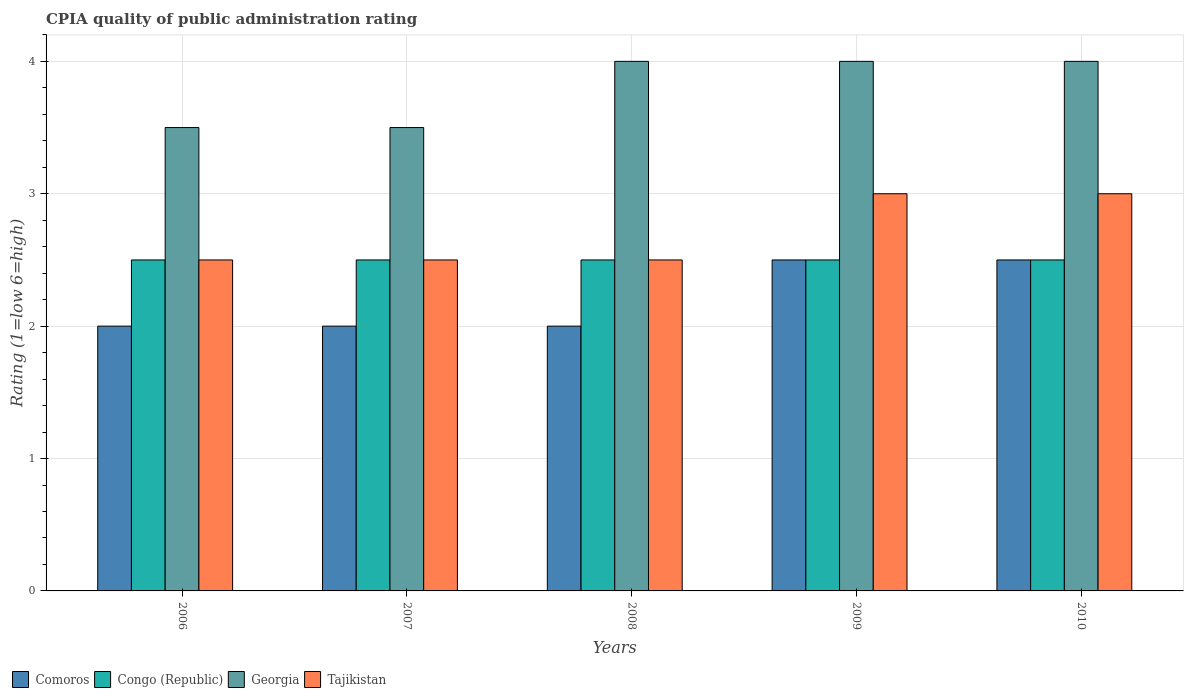How many different coloured bars are there?
Offer a terse response. 4. How many groups of bars are there?
Your response must be concise. 5. Are the number of bars per tick equal to the number of legend labels?
Ensure brevity in your answer.  Yes. Are the number of bars on each tick of the X-axis equal?
Provide a short and direct response. Yes. How many bars are there on the 4th tick from the right?
Your answer should be very brief. 4. What is the CPIA rating in Comoros in 2009?
Your response must be concise. 2.5. In which year was the CPIA rating in Tajikistan maximum?
Provide a succinct answer. 2009. In which year was the CPIA rating in Tajikistan minimum?
Offer a terse response. 2006. What is the total CPIA rating in Tajikistan in the graph?
Your answer should be compact. 13.5. What is the difference between the CPIA rating in Tajikistan in 2007 and that in 2008?
Provide a succinct answer. 0. What is the average CPIA rating in Georgia per year?
Ensure brevity in your answer.  3.8. In the year 2010, what is the difference between the CPIA rating in Georgia and CPIA rating in Tajikistan?
Give a very brief answer. 1. In how many years, is the CPIA rating in Georgia greater than 2.6?
Ensure brevity in your answer.  5. What is the difference between the highest and the second highest CPIA rating in Comoros?
Offer a terse response. 0. Is it the case that in every year, the sum of the CPIA rating in Comoros and CPIA rating in Tajikistan is greater than the sum of CPIA rating in Congo (Republic) and CPIA rating in Georgia?
Your answer should be compact. No. What does the 2nd bar from the left in 2009 represents?
Make the answer very short. Congo (Republic). What does the 1st bar from the right in 2009 represents?
Offer a terse response. Tajikistan. How many bars are there?
Ensure brevity in your answer.  20. Does the graph contain any zero values?
Keep it short and to the point. No. Where does the legend appear in the graph?
Your response must be concise. Bottom left. How are the legend labels stacked?
Your response must be concise. Horizontal. What is the title of the graph?
Offer a terse response. CPIA quality of public administration rating. Does "Kenya" appear as one of the legend labels in the graph?
Give a very brief answer. No. What is the label or title of the X-axis?
Give a very brief answer. Years. What is the Rating (1=low 6=high) of Comoros in 2006?
Offer a very short reply. 2. What is the Rating (1=low 6=high) of Tajikistan in 2006?
Provide a succinct answer. 2.5. What is the Rating (1=low 6=high) of Congo (Republic) in 2007?
Your response must be concise. 2.5. What is the Rating (1=low 6=high) of Georgia in 2008?
Give a very brief answer. 4. What is the Rating (1=low 6=high) of Tajikistan in 2009?
Offer a terse response. 3. What is the Rating (1=low 6=high) of Tajikistan in 2010?
Keep it short and to the point. 3. Across all years, what is the maximum Rating (1=low 6=high) in Congo (Republic)?
Provide a succinct answer. 2.5. Across all years, what is the maximum Rating (1=low 6=high) in Tajikistan?
Your response must be concise. 3. Across all years, what is the minimum Rating (1=low 6=high) of Georgia?
Make the answer very short. 3.5. Across all years, what is the minimum Rating (1=low 6=high) in Tajikistan?
Provide a succinct answer. 2.5. What is the total Rating (1=low 6=high) of Comoros in the graph?
Provide a short and direct response. 11. What is the total Rating (1=low 6=high) in Congo (Republic) in the graph?
Offer a terse response. 12.5. What is the total Rating (1=low 6=high) in Georgia in the graph?
Offer a very short reply. 19. What is the total Rating (1=low 6=high) of Tajikistan in the graph?
Provide a succinct answer. 13.5. What is the difference between the Rating (1=low 6=high) in Comoros in 2006 and that in 2007?
Make the answer very short. 0. What is the difference between the Rating (1=low 6=high) in Congo (Republic) in 2006 and that in 2007?
Provide a short and direct response. 0. What is the difference between the Rating (1=low 6=high) of Georgia in 2006 and that in 2007?
Keep it short and to the point. 0. What is the difference between the Rating (1=low 6=high) of Tajikistan in 2006 and that in 2007?
Provide a short and direct response. 0. What is the difference between the Rating (1=low 6=high) in Comoros in 2006 and that in 2008?
Offer a very short reply. 0. What is the difference between the Rating (1=low 6=high) of Comoros in 2006 and that in 2009?
Offer a very short reply. -0.5. What is the difference between the Rating (1=low 6=high) of Congo (Republic) in 2006 and that in 2009?
Make the answer very short. 0. What is the difference between the Rating (1=low 6=high) in Comoros in 2006 and that in 2010?
Provide a succinct answer. -0.5. What is the difference between the Rating (1=low 6=high) in Tajikistan in 2006 and that in 2010?
Give a very brief answer. -0.5. What is the difference between the Rating (1=low 6=high) in Georgia in 2007 and that in 2008?
Offer a very short reply. -0.5. What is the difference between the Rating (1=low 6=high) of Tajikistan in 2007 and that in 2008?
Give a very brief answer. 0. What is the difference between the Rating (1=low 6=high) of Congo (Republic) in 2007 and that in 2009?
Offer a terse response. 0. What is the difference between the Rating (1=low 6=high) in Tajikistan in 2007 and that in 2009?
Keep it short and to the point. -0.5. What is the difference between the Rating (1=low 6=high) in Comoros in 2007 and that in 2010?
Offer a terse response. -0.5. What is the difference between the Rating (1=low 6=high) of Georgia in 2007 and that in 2010?
Give a very brief answer. -0.5. What is the difference between the Rating (1=low 6=high) in Tajikistan in 2007 and that in 2010?
Keep it short and to the point. -0.5. What is the difference between the Rating (1=low 6=high) of Comoros in 2008 and that in 2009?
Provide a short and direct response. -0.5. What is the difference between the Rating (1=low 6=high) in Congo (Republic) in 2008 and that in 2009?
Provide a succinct answer. 0. What is the difference between the Rating (1=low 6=high) in Georgia in 2008 and that in 2009?
Keep it short and to the point. 0. What is the difference between the Rating (1=low 6=high) in Comoros in 2008 and that in 2010?
Your response must be concise. -0.5. What is the difference between the Rating (1=low 6=high) of Congo (Republic) in 2008 and that in 2010?
Provide a short and direct response. 0. What is the difference between the Rating (1=low 6=high) of Georgia in 2008 and that in 2010?
Offer a terse response. 0. What is the difference between the Rating (1=low 6=high) of Comoros in 2009 and that in 2010?
Offer a terse response. 0. What is the difference between the Rating (1=low 6=high) of Georgia in 2009 and that in 2010?
Your response must be concise. 0. What is the difference between the Rating (1=low 6=high) of Tajikistan in 2009 and that in 2010?
Your answer should be very brief. 0. What is the difference between the Rating (1=low 6=high) of Comoros in 2006 and the Rating (1=low 6=high) of Congo (Republic) in 2007?
Offer a terse response. -0.5. What is the difference between the Rating (1=low 6=high) of Comoros in 2006 and the Rating (1=low 6=high) of Georgia in 2007?
Give a very brief answer. -1.5. What is the difference between the Rating (1=low 6=high) in Comoros in 2006 and the Rating (1=low 6=high) in Tajikistan in 2007?
Your response must be concise. -0.5. What is the difference between the Rating (1=low 6=high) of Congo (Republic) in 2006 and the Rating (1=low 6=high) of Georgia in 2007?
Provide a short and direct response. -1. What is the difference between the Rating (1=low 6=high) in Comoros in 2006 and the Rating (1=low 6=high) in Georgia in 2008?
Give a very brief answer. -2. What is the difference between the Rating (1=low 6=high) in Comoros in 2006 and the Rating (1=low 6=high) in Tajikistan in 2008?
Offer a very short reply. -0.5. What is the difference between the Rating (1=low 6=high) of Congo (Republic) in 2006 and the Rating (1=low 6=high) of Georgia in 2008?
Keep it short and to the point. -1.5. What is the difference between the Rating (1=low 6=high) in Congo (Republic) in 2006 and the Rating (1=low 6=high) in Tajikistan in 2008?
Make the answer very short. 0. What is the difference between the Rating (1=low 6=high) in Georgia in 2006 and the Rating (1=low 6=high) in Tajikistan in 2008?
Your answer should be very brief. 1. What is the difference between the Rating (1=low 6=high) in Comoros in 2006 and the Rating (1=low 6=high) in Georgia in 2009?
Provide a short and direct response. -2. What is the difference between the Rating (1=low 6=high) in Comoros in 2006 and the Rating (1=low 6=high) in Tajikistan in 2009?
Give a very brief answer. -1. What is the difference between the Rating (1=low 6=high) in Congo (Republic) in 2006 and the Rating (1=low 6=high) in Georgia in 2009?
Your answer should be very brief. -1.5. What is the difference between the Rating (1=low 6=high) of Congo (Republic) in 2006 and the Rating (1=low 6=high) of Tajikistan in 2009?
Offer a terse response. -0.5. What is the difference between the Rating (1=low 6=high) of Georgia in 2006 and the Rating (1=low 6=high) of Tajikistan in 2009?
Your response must be concise. 0.5. What is the difference between the Rating (1=low 6=high) of Comoros in 2006 and the Rating (1=low 6=high) of Congo (Republic) in 2010?
Provide a succinct answer. -0.5. What is the difference between the Rating (1=low 6=high) in Comoros in 2006 and the Rating (1=low 6=high) in Tajikistan in 2010?
Offer a terse response. -1. What is the difference between the Rating (1=low 6=high) of Comoros in 2007 and the Rating (1=low 6=high) of Georgia in 2008?
Offer a terse response. -2. What is the difference between the Rating (1=low 6=high) in Comoros in 2007 and the Rating (1=low 6=high) in Tajikistan in 2008?
Make the answer very short. -0.5. What is the difference between the Rating (1=low 6=high) in Georgia in 2007 and the Rating (1=low 6=high) in Tajikistan in 2008?
Ensure brevity in your answer.  1. What is the difference between the Rating (1=low 6=high) of Comoros in 2007 and the Rating (1=low 6=high) of Congo (Republic) in 2009?
Ensure brevity in your answer.  -0.5. What is the difference between the Rating (1=low 6=high) in Comoros in 2007 and the Rating (1=low 6=high) in Tajikistan in 2009?
Your answer should be very brief. -1. What is the difference between the Rating (1=low 6=high) of Georgia in 2007 and the Rating (1=low 6=high) of Tajikistan in 2009?
Provide a succinct answer. 0.5. What is the difference between the Rating (1=low 6=high) of Comoros in 2007 and the Rating (1=low 6=high) of Tajikistan in 2010?
Your answer should be very brief. -1. What is the difference between the Rating (1=low 6=high) of Congo (Republic) in 2007 and the Rating (1=low 6=high) of Georgia in 2010?
Ensure brevity in your answer.  -1.5. What is the difference between the Rating (1=low 6=high) of Congo (Republic) in 2007 and the Rating (1=low 6=high) of Tajikistan in 2010?
Offer a very short reply. -0.5. What is the difference between the Rating (1=low 6=high) in Comoros in 2008 and the Rating (1=low 6=high) in Georgia in 2009?
Give a very brief answer. -2. What is the difference between the Rating (1=low 6=high) in Congo (Republic) in 2008 and the Rating (1=low 6=high) in Georgia in 2009?
Your response must be concise. -1.5. What is the difference between the Rating (1=low 6=high) in Congo (Republic) in 2008 and the Rating (1=low 6=high) in Tajikistan in 2009?
Give a very brief answer. -0.5. What is the difference between the Rating (1=low 6=high) in Georgia in 2008 and the Rating (1=low 6=high) in Tajikistan in 2009?
Ensure brevity in your answer.  1. What is the difference between the Rating (1=low 6=high) of Comoros in 2008 and the Rating (1=low 6=high) of Georgia in 2010?
Make the answer very short. -2. What is the difference between the Rating (1=low 6=high) in Comoros in 2008 and the Rating (1=low 6=high) in Tajikistan in 2010?
Offer a very short reply. -1. What is the difference between the Rating (1=low 6=high) of Congo (Republic) in 2008 and the Rating (1=low 6=high) of Tajikistan in 2010?
Ensure brevity in your answer.  -0.5. What is the difference between the Rating (1=low 6=high) of Comoros in 2009 and the Rating (1=low 6=high) of Georgia in 2010?
Your response must be concise. -1.5. What is the difference between the Rating (1=low 6=high) in Comoros in 2009 and the Rating (1=low 6=high) in Tajikistan in 2010?
Your response must be concise. -0.5. What is the difference between the Rating (1=low 6=high) in Congo (Republic) in 2009 and the Rating (1=low 6=high) in Georgia in 2010?
Give a very brief answer. -1.5. What is the average Rating (1=low 6=high) in Comoros per year?
Your answer should be very brief. 2.2. What is the average Rating (1=low 6=high) in Congo (Republic) per year?
Offer a terse response. 2.5. What is the average Rating (1=low 6=high) in Georgia per year?
Ensure brevity in your answer.  3.8. What is the average Rating (1=low 6=high) in Tajikistan per year?
Your response must be concise. 2.7. In the year 2006, what is the difference between the Rating (1=low 6=high) of Congo (Republic) and Rating (1=low 6=high) of Tajikistan?
Your response must be concise. 0. In the year 2007, what is the difference between the Rating (1=low 6=high) of Comoros and Rating (1=low 6=high) of Congo (Republic)?
Make the answer very short. -0.5. In the year 2007, what is the difference between the Rating (1=low 6=high) in Comoros and Rating (1=low 6=high) in Georgia?
Keep it short and to the point. -1.5. In the year 2007, what is the difference between the Rating (1=low 6=high) of Comoros and Rating (1=low 6=high) of Tajikistan?
Provide a short and direct response. -0.5. In the year 2007, what is the difference between the Rating (1=low 6=high) of Congo (Republic) and Rating (1=low 6=high) of Tajikistan?
Keep it short and to the point. 0. In the year 2007, what is the difference between the Rating (1=low 6=high) in Georgia and Rating (1=low 6=high) in Tajikistan?
Ensure brevity in your answer.  1. In the year 2008, what is the difference between the Rating (1=low 6=high) in Comoros and Rating (1=low 6=high) in Georgia?
Your answer should be very brief. -2. In the year 2008, what is the difference between the Rating (1=low 6=high) in Georgia and Rating (1=low 6=high) in Tajikistan?
Provide a short and direct response. 1.5. In the year 2009, what is the difference between the Rating (1=low 6=high) in Congo (Republic) and Rating (1=low 6=high) in Georgia?
Your answer should be compact. -1.5. In the year 2009, what is the difference between the Rating (1=low 6=high) in Congo (Republic) and Rating (1=low 6=high) in Tajikistan?
Provide a succinct answer. -0.5. In the year 2009, what is the difference between the Rating (1=low 6=high) of Georgia and Rating (1=low 6=high) of Tajikistan?
Provide a succinct answer. 1. In the year 2010, what is the difference between the Rating (1=low 6=high) of Comoros and Rating (1=low 6=high) of Georgia?
Keep it short and to the point. -1.5. In the year 2010, what is the difference between the Rating (1=low 6=high) in Comoros and Rating (1=low 6=high) in Tajikistan?
Your answer should be compact. -0.5. In the year 2010, what is the difference between the Rating (1=low 6=high) in Congo (Republic) and Rating (1=low 6=high) in Georgia?
Your answer should be very brief. -1.5. In the year 2010, what is the difference between the Rating (1=low 6=high) of Congo (Republic) and Rating (1=low 6=high) of Tajikistan?
Offer a terse response. -0.5. In the year 2010, what is the difference between the Rating (1=low 6=high) of Georgia and Rating (1=low 6=high) of Tajikistan?
Provide a short and direct response. 1. What is the ratio of the Rating (1=low 6=high) in Congo (Republic) in 2006 to that in 2007?
Keep it short and to the point. 1. What is the ratio of the Rating (1=low 6=high) in Comoros in 2006 to that in 2008?
Offer a very short reply. 1. What is the ratio of the Rating (1=low 6=high) of Congo (Republic) in 2006 to that in 2008?
Your answer should be very brief. 1. What is the ratio of the Rating (1=low 6=high) of Tajikistan in 2006 to that in 2008?
Ensure brevity in your answer.  1. What is the ratio of the Rating (1=low 6=high) in Congo (Republic) in 2006 to that in 2009?
Offer a very short reply. 1. What is the ratio of the Rating (1=low 6=high) of Georgia in 2006 to that in 2009?
Your answer should be very brief. 0.88. What is the ratio of the Rating (1=low 6=high) in Georgia in 2006 to that in 2010?
Your answer should be compact. 0.88. What is the ratio of the Rating (1=low 6=high) in Tajikistan in 2006 to that in 2010?
Provide a short and direct response. 0.83. What is the ratio of the Rating (1=low 6=high) of Congo (Republic) in 2007 to that in 2008?
Give a very brief answer. 1. What is the ratio of the Rating (1=low 6=high) of Tajikistan in 2007 to that in 2008?
Your response must be concise. 1. What is the ratio of the Rating (1=low 6=high) of Congo (Republic) in 2007 to that in 2009?
Give a very brief answer. 1. What is the ratio of the Rating (1=low 6=high) of Tajikistan in 2007 to that in 2010?
Offer a very short reply. 0.83. What is the ratio of the Rating (1=low 6=high) of Georgia in 2008 to that in 2009?
Provide a short and direct response. 1. What is the ratio of the Rating (1=low 6=high) of Comoros in 2008 to that in 2010?
Provide a succinct answer. 0.8. What is the ratio of the Rating (1=low 6=high) of Tajikistan in 2008 to that in 2010?
Your answer should be compact. 0.83. What is the ratio of the Rating (1=low 6=high) of Comoros in 2009 to that in 2010?
Ensure brevity in your answer.  1. What is the ratio of the Rating (1=low 6=high) of Tajikistan in 2009 to that in 2010?
Give a very brief answer. 1. What is the difference between the highest and the second highest Rating (1=low 6=high) in Congo (Republic)?
Provide a short and direct response. 0. What is the difference between the highest and the second highest Rating (1=low 6=high) in Georgia?
Offer a terse response. 0. What is the difference between the highest and the lowest Rating (1=low 6=high) of Tajikistan?
Your answer should be very brief. 0.5. 